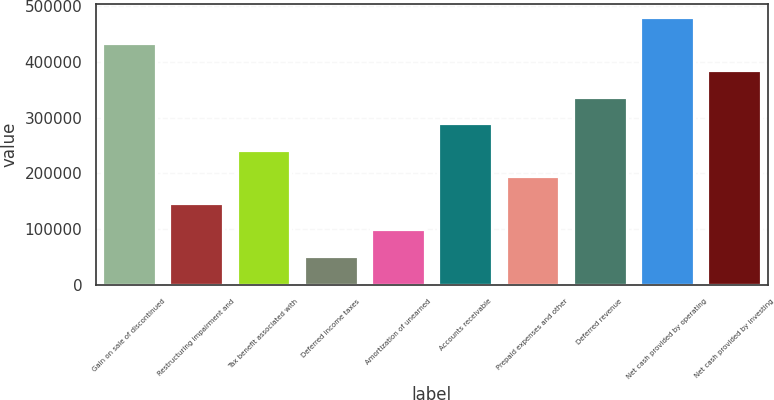<chart> <loc_0><loc_0><loc_500><loc_500><bar_chart><fcel>Gain on sale of discontinued<fcel>Restructuring impairment and<fcel>Tax benefit associated with<fcel>Deferred income taxes<fcel>Amortization of unearned<fcel>Accounts receivable<fcel>Prepaid expenses and other<fcel>Deferred revenue<fcel>Net cash provided by operating<fcel>Net cash provided by investing<nl><fcel>433471<fcel>147567<fcel>242868<fcel>52265.7<fcel>99916.4<fcel>290519<fcel>195218<fcel>338170<fcel>481122<fcel>385821<nl></chart> 